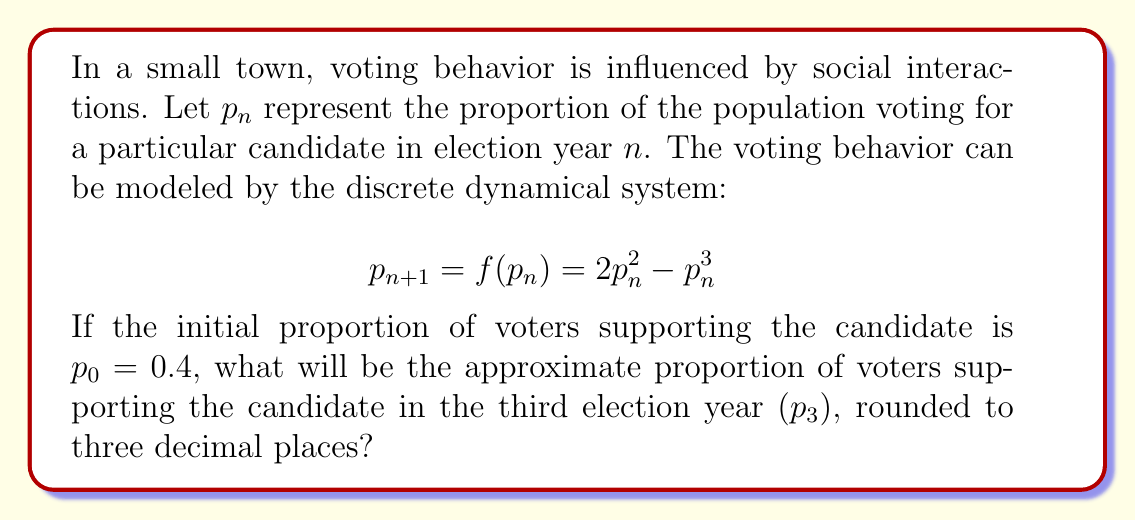Could you help me with this problem? To solve this problem, we need to iterate the given function three times, starting with the initial value of $p_0 = 0.4$. Let's go through this step-by-step:

1) First, we calculate $p_1$:
   $p_1 = f(p_0) = 2(0.4)^2 - (0.4)^3$
   $p_1 = 2(0.16) - 0.064 = 0.32 - 0.064 = 0.256$

2) Next, we calculate $p_2$:
   $p_2 = f(p_1) = 2(0.256)^2 - (0.256)^3$
   $p_2 = 2(0.065536) - 0.016777216$
   $p_2 = 0.131072 - 0.016777216 = 0.114294784$

3) Finally, we calculate $p_3$:
   $p_3 = f(p_2) = 2(0.114294784)^2 - (0.114294784)^3$
   $p_3 = 2(0.013063311) - 0.001493063$
   $p_3 = 0.026126622 - 0.001493063 = 0.024633559$

4) Rounding to three decimal places:
   $p_3 \approx 0.025$

This result shows that the proportion of voters supporting the candidate decreases over time in this model, which could be due to various sociological factors represented by the quadratic and cubic terms in the function.
Answer: 0.025 